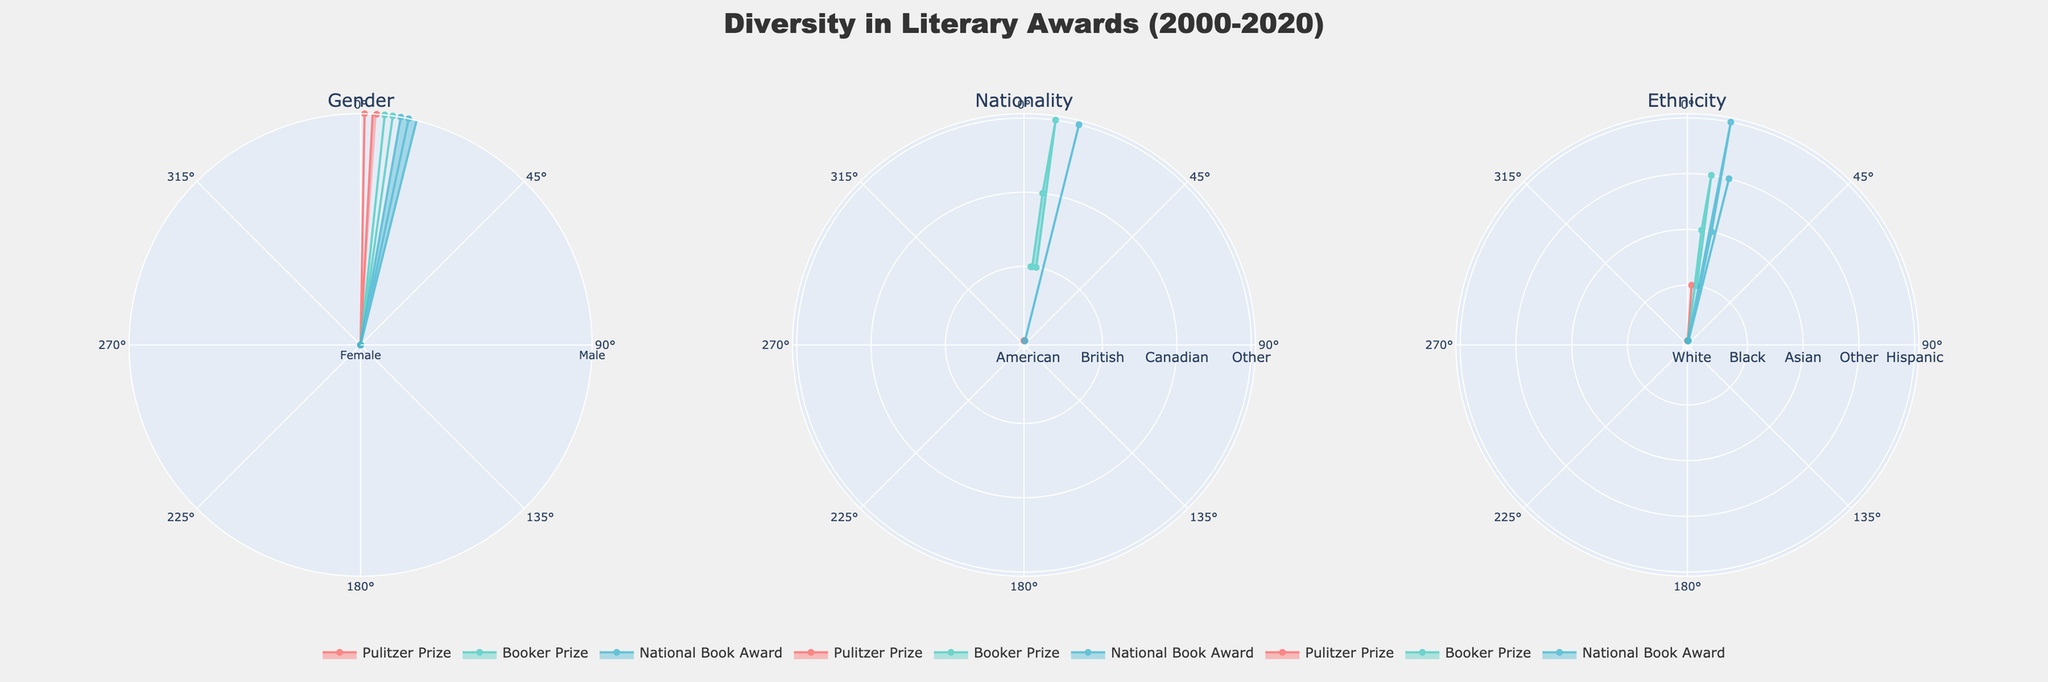What are the subplot titles shown in the figure? The subplot titles in the figure represent the categories being evaluated, which are indicated at the top of each subplot. These categories are derived from the data columns corresponding to different diversity aspects.
Answer: Gender, Nationality, Ethnicity How many types of Nationality categories are represented in the radar chart for the Booker Prize in 2020? In the radar chart for the Booker Prize in 2020, the Nationality categories represented are derived from the dataset for the specified year and award. By examining the radar chart, you can see the distinct Nationality bands.
Answer: One (British) Which gender category won the Pulitzer Prize in 2015? To determine the winning gender category, look at the radar chart under the Gender category subplot for the year 2015 and for the Pulitzer Prize. Each line or area represents a specific award and year combination.
Answer: Non-Binary How does the Ethnicity category compare for the Booker Prize winners between 2005 and 2010? To compare Ethnicity categories, examine the radar chart under the Ethnicity subplot for the Booker Prize in the years 2005 and 2010. Analyze the filled areas or lines to see the differences between the two years.
Answer: 2005 Asian; 2010 Asian Which award shows the most diversity in Nationality categories in 2020? To identify which award shows the most diversity, look at the radar chart under the Nationality subplot and evaluate the filled areas' spread across various nationality categories for the year 2020. More spread indicates more diversity.
Answer: National Book Award Are there any years where the Pulitzer Prize was won by someone who is Non-Binary and of White ethnicity? Check the radar chart intersecting the Gender and Ethnicity subplots for Pulitzer Prize winners. Look for Non-Binary in Gender and White in Ethnicity for any overlapping year indicators.
Answer: Yes, 2015 Compare the gender diversity of National Book Award winners over the two decades. To compare, review the Gender category radar chart. Assess how the filled areas or lines representing the National Book Award winners differ in gender between the years 2000 and 2020.
Answer: Mixed (Male, Female, Non-Binary) Which ethnicity won the Booker Prize in 2020? To find the ethnicity, inspect the radar chart under the Ethnicity subplot for the Booker Prize in 2020. Evaluate the corresponding line or area for that year and award.
Answer: Black How many Non-Binary winners were there in the whole two-decade span across all awards and years? Sum the number of occurrences of Non-Binary winners across all categories and years from the Gender radar charts. Each radar chart will have indicators reflecting Non-Binary counts.
Answer: Two 